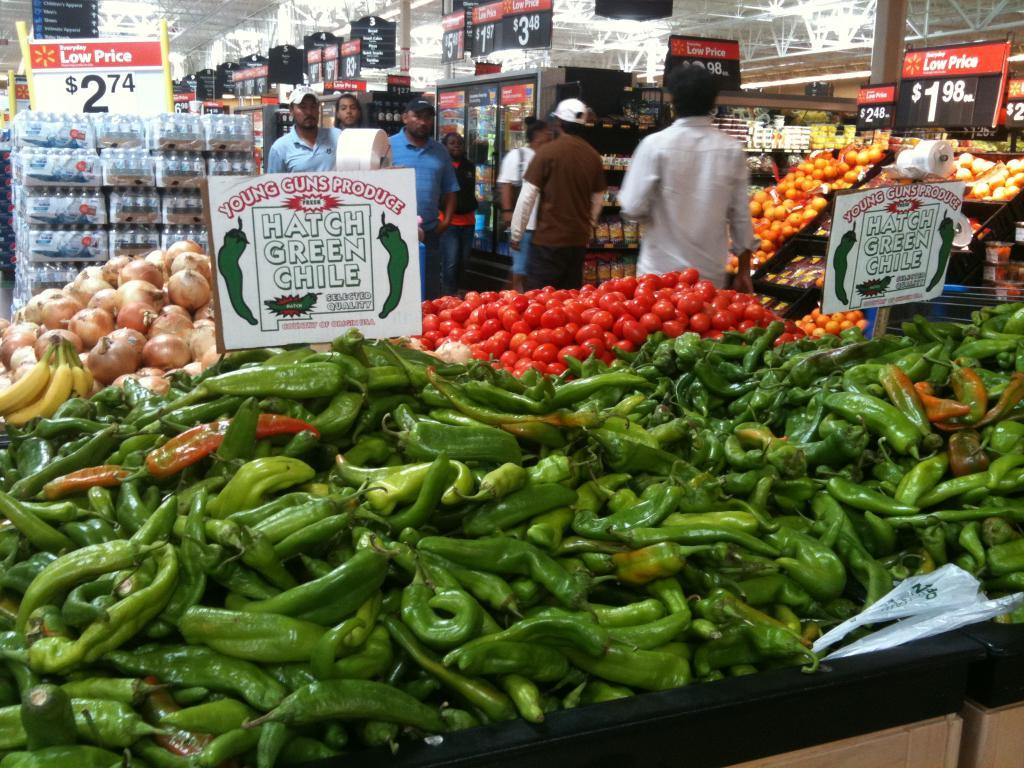What type of food items can be seen in the image? There are vegetables and bananas in the image. What can be observed in the background of the image? There are food items and other objects in the background of the image. What is the arrangement of the bottles in the image? The bottles are arranged in racks in the image. Are there any people visible in the image? Yes, there are people visible in the image. What type of legal advice can be seen being given in the image? There is no lawyer or legal advice present in the image; it features vegetables, bananas, bottles, and people. 